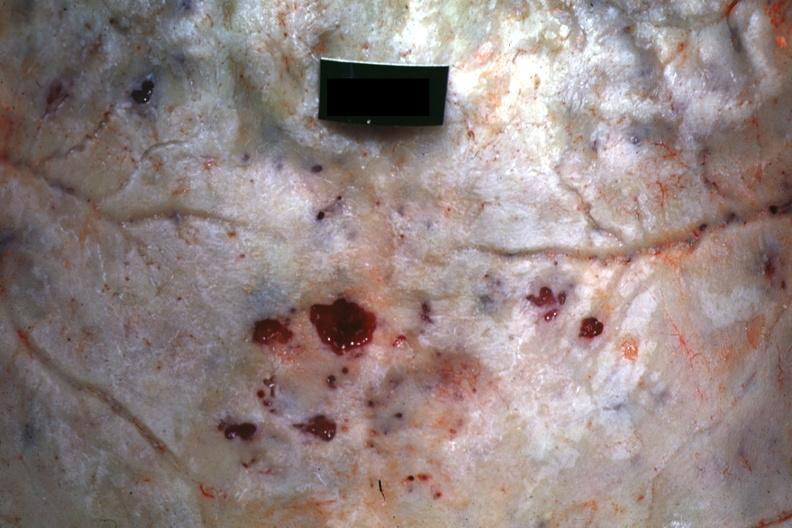what is present?
Answer the question using a single word or phrase. Multiple myeloma 